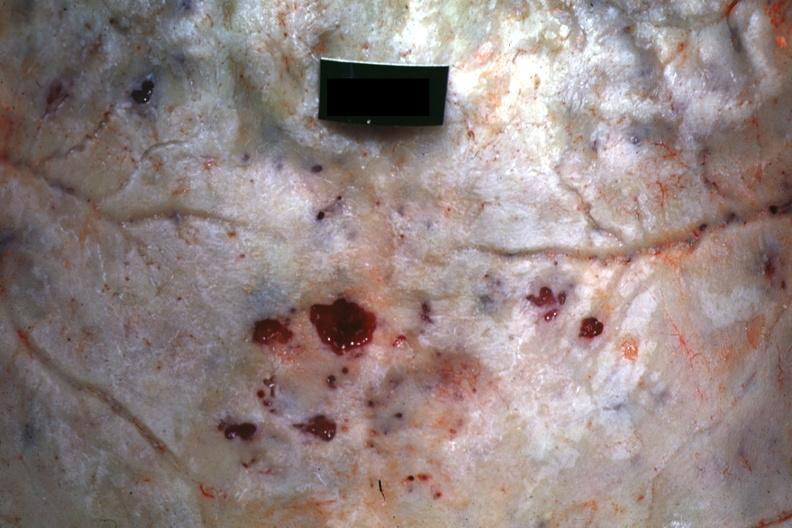what is present?
Answer the question using a single word or phrase. Multiple myeloma 